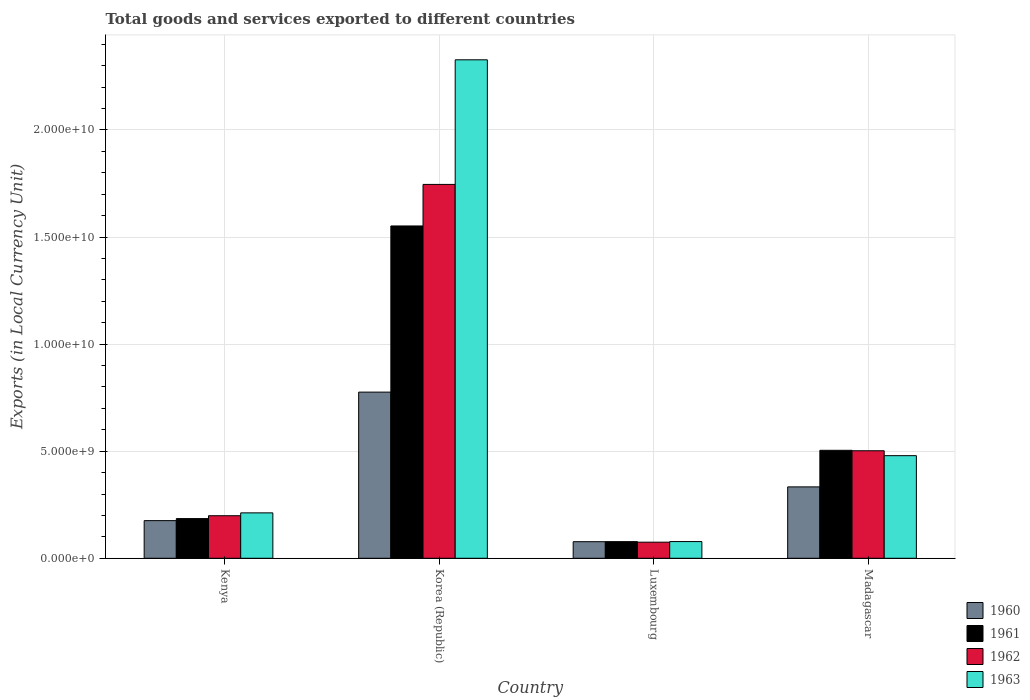How many different coloured bars are there?
Your answer should be compact. 4. How many bars are there on the 1st tick from the right?
Your response must be concise. 4. What is the label of the 4th group of bars from the left?
Your response must be concise. Madagascar. In how many cases, is the number of bars for a given country not equal to the number of legend labels?
Your answer should be very brief. 0. What is the Amount of goods and services exports in 1960 in Korea (Republic)?
Make the answer very short. 7.76e+09. Across all countries, what is the maximum Amount of goods and services exports in 1963?
Offer a terse response. 2.33e+1. Across all countries, what is the minimum Amount of goods and services exports in 1962?
Provide a short and direct response. 7.52e+08. In which country was the Amount of goods and services exports in 1963 maximum?
Provide a short and direct response. Korea (Republic). In which country was the Amount of goods and services exports in 1963 minimum?
Make the answer very short. Luxembourg. What is the total Amount of goods and services exports in 1961 in the graph?
Ensure brevity in your answer.  2.32e+1. What is the difference between the Amount of goods and services exports in 1961 in Kenya and that in Korea (Republic)?
Offer a terse response. -1.37e+1. What is the difference between the Amount of goods and services exports in 1962 in Luxembourg and the Amount of goods and services exports in 1961 in Madagascar?
Offer a very short reply. -4.29e+09. What is the average Amount of goods and services exports in 1960 per country?
Offer a very short reply. 3.41e+09. What is the difference between the Amount of goods and services exports of/in 1961 and Amount of goods and services exports of/in 1963 in Kenya?
Give a very brief answer. -2.67e+08. What is the ratio of the Amount of goods and services exports in 1961 in Korea (Republic) to that in Luxembourg?
Provide a short and direct response. 19.97. Is the difference between the Amount of goods and services exports in 1961 in Kenya and Luxembourg greater than the difference between the Amount of goods and services exports in 1963 in Kenya and Luxembourg?
Your answer should be very brief. No. What is the difference between the highest and the second highest Amount of goods and services exports in 1962?
Make the answer very short. 1.24e+1. What is the difference between the highest and the lowest Amount of goods and services exports in 1962?
Provide a short and direct response. 1.67e+1. Is it the case that in every country, the sum of the Amount of goods and services exports in 1962 and Amount of goods and services exports in 1960 is greater than the sum of Amount of goods and services exports in 1963 and Amount of goods and services exports in 1961?
Offer a very short reply. No. What does the 1st bar from the left in Luxembourg represents?
Ensure brevity in your answer.  1960. What does the 3rd bar from the right in Madagascar represents?
Offer a very short reply. 1961. Is it the case that in every country, the sum of the Amount of goods and services exports in 1961 and Amount of goods and services exports in 1960 is greater than the Amount of goods and services exports in 1963?
Offer a very short reply. No. Does the graph contain any zero values?
Provide a succinct answer. No. Does the graph contain grids?
Give a very brief answer. Yes. Where does the legend appear in the graph?
Your response must be concise. Bottom right. What is the title of the graph?
Provide a short and direct response. Total goods and services exported to different countries. Does "1968" appear as one of the legend labels in the graph?
Give a very brief answer. No. What is the label or title of the X-axis?
Your answer should be very brief. Country. What is the label or title of the Y-axis?
Provide a succinct answer. Exports (in Local Currency Unit). What is the Exports (in Local Currency Unit) in 1960 in Kenya?
Your answer should be very brief. 1.76e+09. What is the Exports (in Local Currency Unit) in 1961 in Kenya?
Your answer should be very brief. 1.85e+09. What is the Exports (in Local Currency Unit) in 1962 in Kenya?
Your answer should be compact. 1.99e+09. What is the Exports (in Local Currency Unit) in 1963 in Kenya?
Keep it short and to the point. 2.12e+09. What is the Exports (in Local Currency Unit) of 1960 in Korea (Republic)?
Your response must be concise. 7.76e+09. What is the Exports (in Local Currency Unit) in 1961 in Korea (Republic)?
Give a very brief answer. 1.55e+1. What is the Exports (in Local Currency Unit) in 1962 in Korea (Republic)?
Keep it short and to the point. 1.75e+1. What is the Exports (in Local Currency Unit) in 1963 in Korea (Republic)?
Your answer should be very brief. 2.33e+1. What is the Exports (in Local Currency Unit) of 1960 in Luxembourg?
Provide a succinct answer. 7.74e+08. What is the Exports (in Local Currency Unit) of 1961 in Luxembourg?
Provide a succinct answer. 7.77e+08. What is the Exports (in Local Currency Unit) of 1962 in Luxembourg?
Your answer should be very brief. 7.52e+08. What is the Exports (in Local Currency Unit) in 1963 in Luxembourg?
Provide a succinct answer. 7.80e+08. What is the Exports (in Local Currency Unit) in 1960 in Madagascar?
Give a very brief answer. 3.33e+09. What is the Exports (in Local Currency Unit) of 1961 in Madagascar?
Offer a terse response. 5.04e+09. What is the Exports (in Local Currency Unit) of 1962 in Madagascar?
Make the answer very short. 5.02e+09. What is the Exports (in Local Currency Unit) in 1963 in Madagascar?
Your answer should be compact. 4.79e+09. Across all countries, what is the maximum Exports (in Local Currency Unit) of 1960?
Your response must be concise. 7.76e+09. Across all countries, what is the maximum Exports (in Local Currency Unit) in 1961?
Offer a terse response. 1.55e+1. Across all countries, what is the maximum Exports (in Local Currency Unit) in 1962?
Give a very brief answer. 1.75e+1. Across all countries, what is the maximum Exports (in Local Currency Unit) of 1963?
Keep it short and to the point. 2.33e+1. Across all countries, what is the minimum Exports (in Local Currency Unit) in 1960?
Offer a terse response. 7.74e+08. Across all countries, what is the minimum Exports (in Local Currency Unit) of 1961?
Your answer should be very brief. 7.77e+08. Across all countries, what is the minimum Exports (in Local Currency Unit) of 1962?
Offer a very short reply. 7.52e+08. Across all countries, what is the minimum Exports (in Local Currency Unit) of 1963?
Provide a short and direct response. 7.80e+08. What is the total Exports (in Local Currency Unit) of 1960 in the graph?
Offer a very short reply. 1.36e+1. What is the total Exports (in Local Currency Unit) in 1961 in the graph?
Keep it short and to the point. 2.32e+1. What is the total Exports (in Local Currency Unit) of 1962 in the graph?
Offer a very short reply. 2.52e+1. What is the total Exports (in Local Currency Unit) in 1963 in the graph?
Make the answer very short. 3.10e+1. What is the difference between the Exports (in Local Currency Unit) in 1960 in Kenya and that in Korea (Republic)?
Keep it short and to the point. -6.00e+09. What is the difference between the Exports (in Local Currency Unit) in 1961 in Kenya and that in Korea (Republic)?
Make the answer very short. -1.37e+1. What is the difference between the Exports (in Local Currency Unit) in 1962 in Kenya and that in Korea (Republic)?
Keep it short and to the point. -1.55e+1. What is the difference between the Exports (in Local Currency Unit) of 1963 in Kenya and that in Korea (Republic)?
Your answer should be compact. -2.12e+1. What is the difference between the Exports (in Local Currency Unit) of 1960 in Kenya and that in Luxembourg?
Offer a very short reply. 9.84e+08. What is the difference between the Exports (in Local Currency Unit) in 1961 in Kenya and that in Luxembourg?
Provide a short and direct response. 1.08e+09. What is the difference between the Exports (in Local Currency Unit) of 1962 in Kenya and that in Luxembourg?
Your answer should be very brief. 1.23e+09. What is the difference between the Exports (in Local Currency Unit) in 1963 in Kenya and that in Luxembourg?
Make the answer very short. 1.34e+09. What is the difference between the Exports (in Local Currency Unit) of 1960 in Kenya and that in Madagascar?
Your answer should be compact. -1.58e+09. What is the difference between the Exports (in Local Currency Unit) in 1961 in Kenya and that in Madagascar?
Your response must be concise. -3.19e+09. What is the difference between the Exports (in Local Currency Unit) in 1962 in Kenya and that in Madagascar?
Offer a terse response. -3.03e+09. What is the difference between the Exports (in Local Currency Unit) in 1963 in Kenya and that in Madagascar?
Provide a succinct answer. -2.67e+09. What is the difference between the Exports (in Local Currency Unit) in 1960 in Korea (Republic) and that in Luxembourg?
Provide a succinct answer. 6.98e+09. What is the difference between the Exports (in Local Currency Unit) in 1961 in Korea (Republic) and that in Luxembourg?
Your answer should be compact. 1.47e+1. What is the difference between the Exports (in Local Currency Unit) of 1962 in Korea (Republic) and that in Luxembourg?
Make the answer very short. 1.67e+1. What is the difference between the Exports (in Local Currency Unit) of 1963 in Korea (Republic) and that in Luxembourg?
Ensure brevity in your answer.  2.25e+1. What is the difference between the Exports (in Local Currency Unit) of 1960 in Korea (Republic) and that in Madagascar?
Give a very brief answer. 4.43e+09. What is the difference between the Exports (in Local Currency Unit) of 1961 in Korea (Republic) and that in Madagascar?
Offer a terse response. 1.05e+1. What is the difference between the Exports (in Local Currency Unit) of 1962 in Korea (Republic) and that in Madagascar?
Offer a terse response. 1.24e+1. What is the difference between the Exports (in Local Currency Unit) of 1963 in Korea (Republic) and that in Madagascar?
Give a very brief answer. 1.85e+1. What is the difference between the Exports (in Local Currency Unit) in 1960 in Luxembourg and that in Madagascar?
Ensure brevity in your answer.  -2.56e+09. What is the difference between the Exports (in Local Currency Unit) in 1961 in Luxembourg and that in Madagascar?
Provide a short and direct response. -4.26e+09. What is the difference between the Exports (in Local Currency Unit) of 1962 in Luxembourg and that in Madagascar?
Your answer should be very brief. -4.27e+09. What is the difference between the Exports (in Local Currency Unit) in 1963 in Luxembourg and that in Madagascar?
Your answer should be compact. -4.01e+09. What is the difference between the Exports (in Local Currency Unit) of 1960 in Kenya and the Exports (in Local Currency Unit) of 1961 in Korea (Republic)?
Offer a very short reply. -1.38e+1. What is the difference between the Exports (in Local Currency Unit) in 1960 in Kenya and the Exports (in Local Currency Unit) in 1962 in Korea (Republic)?
Give a very brief answer. -1.57e+1. What is the difference between the Exports (in Local Currency Unit) of 1960 in Kenya and the Exports (in Local Currency Unit) of 1963 in Korea (Republic)?
Keep it short and to the point. -2.15e+1. What is the difference between the Exports (in Local Currency Unit) in 1961 in Kenya and the Exports (in Local Currency Unit) in 1962 in Korea (Republic)?
Make the answer very short. -1.56e+1. What is the difference between the Exports (in Local Currency Unit) of 1961 in Kenya and the Exports (in Local Currency Unit) of 1963 in Korea (Republic)?
Keep it short and to the point. -2.14e+1. What is the difference between the Exports (in Local Currency Unit) of 1962 in Kenya and the Exports (in Local Currency Unit) of 1963 in Korea (Republic)?
Your response must be concise. -2.13e+1. What is the difference between the Exports (in Local Currency Unit) of 1960 in Kenya and the Exports (in Local Currency Unit) of 1961 in Luxembourg?
Make the answer very short. 9.81e+08. What is the difference between the Exports (in Local Currency Unit) of 1960 in Kenya and the Exports (in Local Currency Unit) of 1962 in Luxembourg?
Your response must be concise. 1.01e+09. What is the difference between the Exports (in Local Currency Unit) of 1960 in Kenya and the Exports (in Local Currency Unit) of 1963 in Luxembourg?
Provide a short and direct response. 9.78e+08. What is the difference between the Exports (in Local Currency Unit) in 1961 in Kenya and the Exports (in Local Currency Unit) in 1962 in Luxembourg?
Provide a short and direct response. 1.10e+09. What is the difference between the Exports (in Local Currency Unit) in 1961 in Kenya and the Exports (in Local Currency Unit) in 1963 in Luxembourg?
Give a very brief answer. 1.07e+09. What is the difference between the Exports (in Local Currency Unit) of 1962 in Kenya and the Exports (in Local Currency Unit) of 1963 in Luxembourg?
Ensure brevity in your answer.  1.21e+09. What is the difference between the Exports (in Local Currency Unit) of 1960 in Kenya and the Exports (in Local Currency Unit) of 1961 in Madagascar?
Provide a short and direct response. -3.28e+09. What is the difference between the Exports (in Local Currency Unit) of 1960 in Kenya and the Exports (in Local Currency Unit) of 1962 in Madagascar?
Provide a short and direct response. -3.26e+09. What is the difference between the Exports (in Local Currency Unit) in 1960 in Kenya and the Exports (in Local Currency Unit) in 1963 in Madagascar?
Make the answer very short. -3.03e+09. What is the difference between the Exports (in Local Currency Unit) in 1961 in Kenya and the Exports (in Local Currency Unit) in 1962 in Madagascar?
Your response must be concise. -3.17e+09. What is the difference between the Exports (in Local Currency Unit) of 1961 in Kenya and the Exports (in Local Currency Unit) of 1963 in Madagascar?
Your answer should be very brief. -2.94e+09. What is the difference between the Exports (in Local Currency Unit) in 1962 in Kenya and the Exports (in Local Currency Unit) in 1963 in Madagascar?
Your answer should be compact. -2.80e+09. What is the difference between the Exports (in Local Currency Unit) of 1960 in Korea (Republic) and the Exports (in Local Currency Unit) of 1961 in Luxembourg?
Your response must be concise. 6.98e+09. What is the difference between the Exports (in Local Currency Unit) of 1960 in Korea (Republic) and the Exports (in Local Currency Unit) of 1962 in Luxembourg?
Provide a succinct answer. 7.01e+09. What is the difference between the Exports (in Local Currency Unit) of 1960 in Korea (Republic) and the Exports (in Local Currency Unit) of 1963 in Luxembourg?
Provide a succinct answer. 6.98e+09. What is the difference between the Exports (in Local Currency Unit) in 1961 in Korea (Republic) and the Exports (in Local Currency Unit) in 1962 in Luxembourg?
Make the answer very short. 1.48e+1. What is the difference between the Exports (in Local Currency Unit) in 1961 in Korea (Republic) and the Exports (in Local Currency Unit) in 1963 in Luxembourg?
Provide a short and direct response. 1.47e+1. What is the difference between the Exports (in Local Currency Unit) in 1962 in Korea (Republic) and the Exports (in Local Currency Unit) in 1963 in Luxembourg?
Your answer should be very brief. 1.67e+1. What is the difference between the Exports (in Local Currency Unit) in 1960 in Korea (Republic) and the Exports (in Local Currency Unit) in 1961 in Madagascar?
Ensure brevity in your answer.  2.72e+09. What is the difference between the Exports (in Local Currency Unit) of 1960 in Korea (Republic) and the Exports (in Local Currency Unit) of 1962 in Madagascar?
Keep it short and to the point. 2.74e+09. What is the difference between the Exports (in Local Currency Unit) in 1960 in Korea (Republic) and the Exports (in Local Currency Unit) in 1963 in Madagascar?
Your response must be concise. 2.97e+09. What is the difference between the Exports (in Local Currency Unit) of 1961 in Korea (Republic) and the Exports (in Local Currency Unit) of 1962 in Madagascar?
Provide a succinct answer. 1.05e+1. What is the difference between the Exports (in Local Currency Unit) of 1961 in Korea (Republic) and the Exports (in Local Currency Unit) of 1963 in Madagascar?
Offer a very short reply. 1.07e+1. What is the difference between the Exports (in Local Currency Unit) in 1962 in Korea (Republic) and the Exports (in Local Currency Unit) in 1963 in Madagascar?
Make the answer very short. 1.27e+1. What is the difference between the Exports (in Local Currency Unit) in 1960 in Luxembourg and the Exports (in Local Currency Unit) in 1961 in Madagascar?
Give a very brief answer. -4.27e+09. What is the difference between the Exports (in Local Currency Unit) of 1960 in Luxembourg and the Exports (in Local Currency Unit) of 1962 in Madagascar?
Your response must be concise. -4.25e+09. What is the difference between the Exports (in Local Currency Unit) in 1960 in Luxembourg and the Exports (in Local Currency Unit) in 1963 in Madagascar?
Offer a terse response. -4.02e+09. What is the difference between the Exports (in Local Currency Unit) in 1961 in Luxembourg and the Exports (in Local Currency Unit) in 1962 in Madagascar?
Your answer should be very brief. -4.24e+09. What is the difference between the Exports (in Local Currency Unit) in 1961 in Luxembourg and the Exports (in Local Currency Unit) in 1963 in Madagascar?
Your response must be concise. -4.01e+09. What is the difference between the Exports (in Local Currency Unit) in 1962 in Luxembourg and the Exports (in Local Currency Unit) in 1963 in Madagascar?
Make the answer very short. -4.04e+09. What is the average Exports (in Local Currency Unit) of 1960 per country?
Your answer should be compact. 3.41e+09. What is the average Exports (in Local Currency Unit) in 1961 per country?
Ensure brevity in your answer.  5.80e+09. What is the average Exports (in Local Currency Unit) in 1962 per country?
Your answer should be compact. 6.30e+09. What is the average Exports (in Local Currency Unit) of 1963 per country?
Give a very brief answer. 7.74e+09. What is the difference between the Exports (in Local Currency Unit) in 1960 and Exports (in Local Currency Unit) in 1961 in Kenya?
Offer a very short reply. -9.56e+07. What is the difference between the Exports (in Local Currency Unit) of 1960 and Exports (in Local Currency Unit) of 1962 in Kenya?
Make the answer very short. -2.29e+08. What is the difference between the Exports (in Local Currency Unit) in 1960 and Exports (in Local Currency Unit) in 1963 in Kenya?
Provide a succinct answer. -3.63e+08. What is the difference between the Exports (in Local Currency Unit) of 1961 and Exports (in Local Currency Unit) of 1962 in Kenya?
Provide a short and direct response. -1.33e+08. What is the difference between the Exports (in Local Currency Unit) in 1961 and Exports (in Local Currency Unit) in 1963 in Kenya?
Your answer should be very brief. -2.67e+08. What is the difference between the Exports (in Local Currency Unit) of 1962 and Exports (in Local Currency Unit) of 1963 in Kenya?
Give a very brief answer. -1.34e+08. What is the difference between the Exports (in Local Currency Unit) in 1960 and Exports (in Local Currency Unit) in 1961 in Korea (Republic)?
Offer a very short reply. -7.76e+09. What is the difference between the Exports (in Local Currency Unit) in 1960 and Exports (in Local Currency Unit) in 1962 in Korea (Republic)?
Provide a succinct answer. -9.70e+09. What is the difference between the Exports (in Local Currency Unit) of 1960 and Exports (in Local Currency Unit) of 1963 in Korea (Republic)?
Ensure brevity in your answer.  -1.55e+1. What is the difference between the Exports (in Local Currency Unit) in 1961 and Exports (in Local Currency Unit) in 1962 in Korea (Republic)?
Make the answer very short. -1.94e+09. What is the difference between the Exports (in Local Currency Unit) in 1961 and Exports (in Local Currency Unit) in 1963 in Korea (Republic)?
Offer a very short reply. -7.76e+09. What is the difference between the Exports (in Local Currency Unit) in 1962 and Exports (in Local Currency Unit) in 1963 in Korea (Republic)?
Ensure brevity in your answer.  -5.82e+09. What is the difference between the Exports (in Local Currency Unit) in 1960 and Exports (in Local Currency Unit) in 1961 in Luxembourg?
Make the answer very short. -2.86e+06. What is the difference between the Exports (in Local Currency Unit) of 1960 and Exports (in Local Currency Unit) of 1962 in Luxembourg?
Keep it short and to the point. 2.23e+07. What is the difference between the Exports (in Local Currency Unit) in 1960 and Exports (in Local Currency Unit) in 1963 in Luxembourg?
Your answer should be very brief. -5.65e+06. What is the difference between the Exports (in Local Currency Unit) in 1961 and Exports (in Local Currency Unit) in 1962 in Luxembourg?
Provide a short and direct response. 2.52e+07. What is the difference between the Exports (in Local Currency Unit) of 1961 and Exports (in Local Currency Unit) of 1963 in Luxembourg?
Make the answer very short. -2.79e+06. What is the difference between the Exports (in Local Currency Unit) in 1962 and Exports (in Local Currency Unit) in 1963 in Luxembourg?
Your answer should be compact. -2.80e+07. What is the difference between the Exports (in Local Currency Unit) in 1960 and Exports (in Local Currency Unit) in 1961 in Madagascar?
Your answer should be very brief. -1.71e+09. What is the difference between the Exports (in Local Currency Unit) in 1960 and Exports (in Local Currency Unit) in 1962 in Madagascar?
Offer a terse response. -1.69e+09. What is the difference between the Exports (in Local Currency Unit) of 1960 and Exports (in Local Currency Unit) of 1963 in Madagascar?
Your answer should be very brief. -1.46e+09. What is the difference between the Exports (in Local Currency Unit) in 1961 and Exports (in Local Currency Unit) in 1962 in Madagascar?
Provide a succinct answer. 2.08e+07. What is the difference between the Exports (in Local Currency Unit) in 1961 and Exports (in Local Currency Unit) in 1963 in Madagascar?
Provide a short and direct response. 2.50e+08. What is the difference between the Exports (in Local Currency Unit) in 1962 and Exports (in Local Currency Unit) in 1963 in Madagascar?
Provide a succinct answer. 2.29e+08. What is the ratio of the Exports (in Local Currency Unit) in 1960 in Kenya to that in Korea (Republic)?
Your answer should be compact. 0.23. What is the ratio of the Exports (in Local Currency Unit) of 1961 in Kenya to that in Korea (Republic)?
Your answer should be compact. 0.12. What is the ratio of the Exports (in Local Currency Unit) of 1962 in Kenya to that in Korea (Republic)?
Offer a terse response. 0.11. What is the ratio of the Exports (in Local Currency Unit) in 1963 in Kenya to that in Korea (Republic)?
Keep it short and to the point. 0.09. What is the ratio of the Exports (in Local Currency Unit) in 1960 in Kenya to that in Luxembourg?
Offer a terse response. 2.27. What is the ratio of the Exports (in Local Currency Unit) in 1961 in Kenya to that in Luxembourg?
Ensure brevity in your answer.  2.39. What is the ratio of the Exports (in Local Currency Unit) in 1962 in Kenya to that in Luxembourg?
Offer a very short reply. 2.64. What is the ratio of the Exports (in Local Currency Unit) in 1963 in Kenya to that in Luxembourg?
Make the answer very short. 2.72. What is the ratio of the Exports (in Local Currency Unit) of 1960 in Kenya to that in Madagascar?
Your answer should be very brief. 0.53. What is the ratio of the Exports (in Local Currency Unit) of 1961 in Kenya to that in Madagascar?
Your answer should be very brief. 0.37. What is the ratio of the Exports (in Local Currency Unit) of 1962 in Kenya to that in Madagascar?
Your response must be concise. 0.4. What is the ratio of the Exports (in Local Currency Unit) of 1963 in Kenya to that in Madagascar?
Keep it short and to the point. 0.44. What is the ratio of the Exports (in Local Currency Unit) of 1960 in Korea (Republic) to that in Luxembourg?
Make the answer very short. 10.02. What is the ratio of the Exports (in Local Currency Unit) of 1961 in Korea (Republic) to that in Luxembourg?
Your response must be concise. 19.97. What is the ratio of the Exports (in Local Currency Unit) in 1962 in Korea (Republic) to that in Luxembourg?
Ensure brevity in your answer.  23.22. What is the ratio of the Exports (in Local Currency Unit) of 1963 in Korea (Republic) to that in Luxembourg?
Give a very brief answer. 29.85. What is the ratio of the Exports (in Local Currency Unit) in 1960 in Korea (Republic) to that in Madagascar?
Give a very brief answer. 2.33. What is the ratio of the Exports (in Local Currency Unit) of 1961 in Korea (Republic) to that in Madagascar?
Offer a terse response. 3.08. What is the ratio of the Exports (in Local Currency Unit) of 1962 in Korea (Republic) to that in Madagascar?
Provide a short and direct response. 3.48. What is the ratio of the Exports (in Local Currency Unit) in 1963 in Korea (Republic) to that in Madagascar?
Offer a terse response. 4.86. What is the ratio of the Exports (in Local Currency Unit) in 1960 in Luxembourg to that in Madagascar?
Give a very brief answer. 0.23. What is the ratio of the Exports (in Local Currency Unit) in 1961 in Luxembourg to that in Madagascar?
Provide a succinct answer. 0.15. What is the ratio of the Exports (in Local Currency Unit) in 1962 in Luxembourg to that in Madagascar?
Offer a terse response. 0.15. What is the ratio of the Exports (in Local Currency Unit) in 1963 in Luxembourg to that in Madagascar?
Provide a succinct answer. 0.16. What is the difference between the highest and the second highest Exports (in Local Currency Unit) of 1960?
Your answer should be compact. 4.43e+09. What is the difference between the highest and the second highest Exports (in Local Currency Unit) of 1961?
Give a very brief answer. 1.05e+1. What is the difference between the highest and the second highest Exports (in Local Currency Unit) of 1962?
Give a very brief answer. 1.24e+1. What is the difference between the highest and the second highest Exports (in Local Currency Unit) in 1963?
Offer a very short reply. 1.85e+1. What is the difference between the highest and the lowest Exports (in Local Currency Unit) of 1960?
Make the answer very short. 6.98e+09. What is the difference between the highest and the lowest Exports (in Local Currency Unit) of 1961?
Give a very brief answer. 1.47e+1. What is the difference between the highest and the lowest Exports (in Local Currency Unit) of 1962?
Your answer should be compact. 1.67e+1. What is the difference between the highest and the lowest Exports (in Local Currency Unit) of 1963?
Your answer should be very brief. 2.25e+1. 